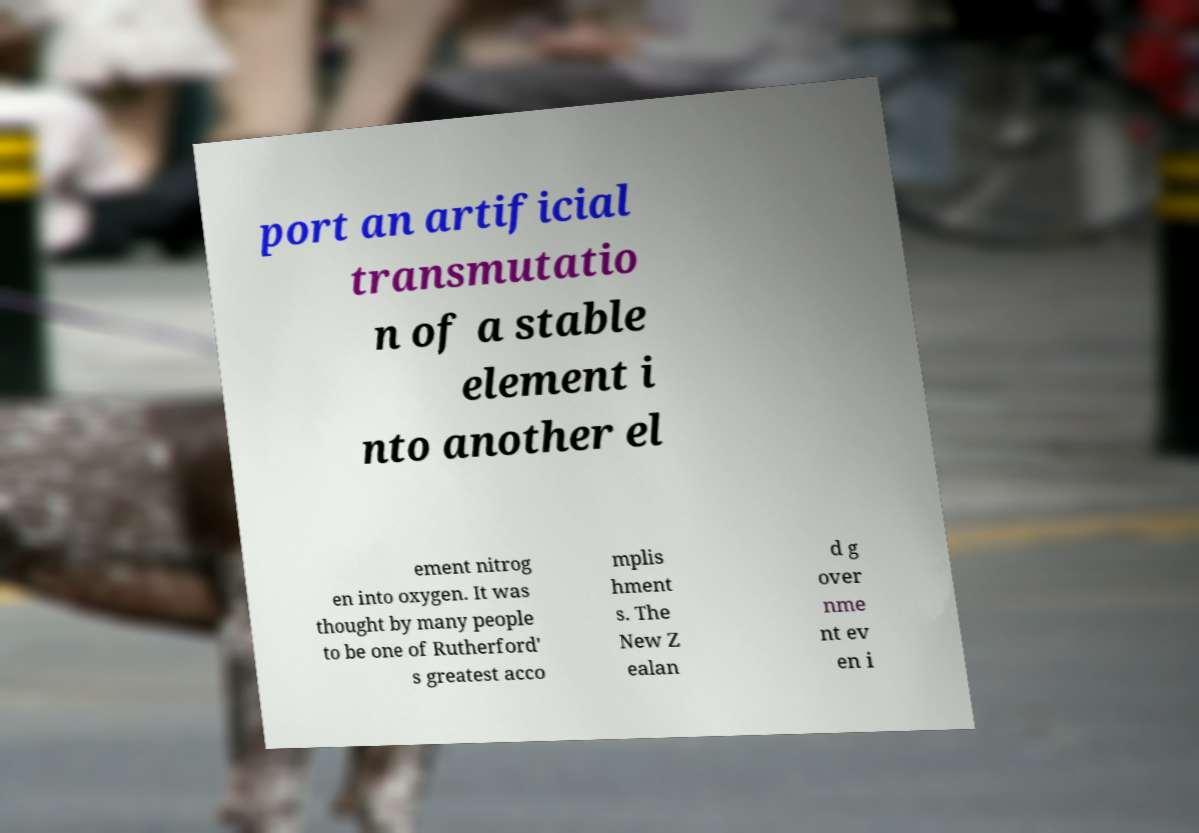Can you read and provide the text displayed in the image?This photo seems to have some interesting text. Can you extract and type it out for me? port an artificial transmutatio n of a stable element i nto another el ement nitrog en into oxygen. It was thought by many people to be one of Rutherford' s greatest acco mplis hment s. The New Z ealan d g over nme nt ev en i 